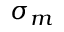Convert formula to latex. <formula><loc_0><loc_0><loc_500><loc_500>\sigma _ { m }</formula> 